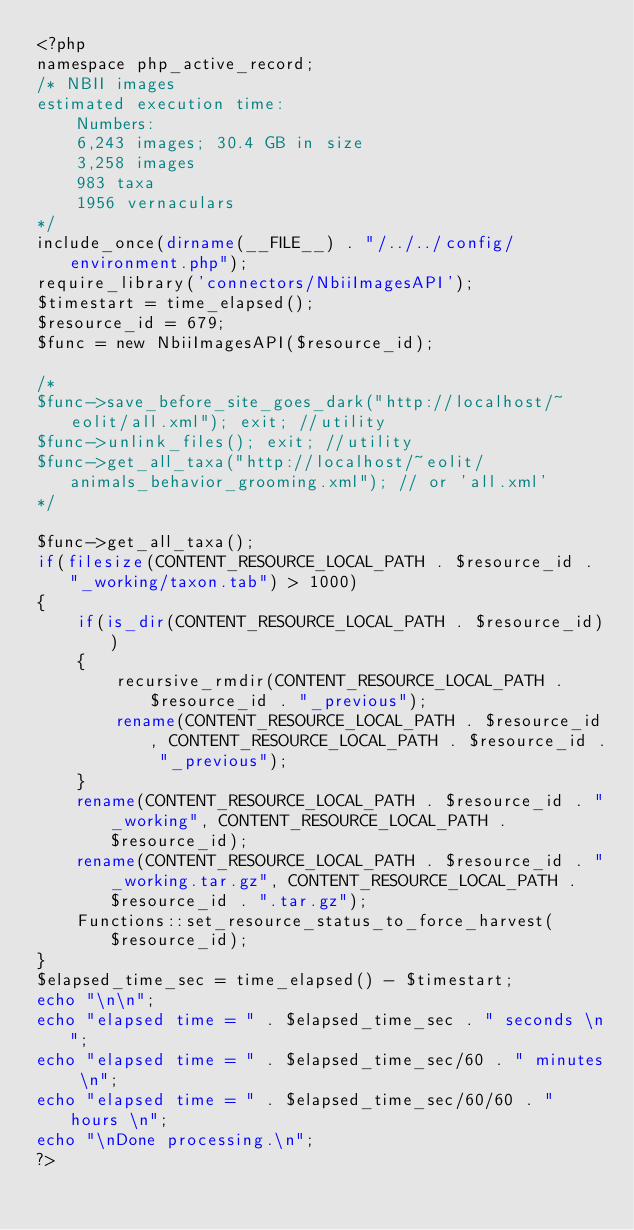<code> <loc_0><loc_0><loc_500><loc_500><_PHP_><?php
namespace php_active_record;
/* NBII images
estimated execution time: 
    Numbers:
    6,243 images; 30.4 GB in size
    3,258 images
    983 taxa
    1956 vernaculars
*/
include_once(dirname(__FILE__) . "/../../config/environment.php");
require_library('connectors/NbiiImagesAPI');
$timestart = time_elapsed();
$resource_id = 679;
$func = new NbiiImagesAPI($resource_id);

/* 
$func->save_before_site_goes_dark("http://localhost/~eolit/all.xml"); exit; //utility
$func->unlink_files(); exit; //utility 
$func->get_all_taxa("http://localhost/~eolit/animals_behavior_grooming.xml"); // or 'all.xml'
*/

$func->get_all_taxa();
if(filesize(CONTENT_RESOURCE_LOCAL_PATH . $resource_id . "_working/taxon.tab") > 1000)
{
    if(is_dir(CONTENT_RESOURCE_LOCAL_PATH . $resource_id))
    {
        recursive_rmdir(CONTENT_RESOURCE_LOCAL_PATH . $resource_id . "_previous");
        rename(CONTENT_RESOURCE_LOCAL_PATH . $resource_id, CONTENT_RESOURCE_LOCAL_PATH . $resource_id . "_previous");
    }
    rename(CONTENT_RESOURCE_LOCAL_PATH . $resource_id . "_working", CONTENT_RESOURCE_LOCAL_PATH . $resource_id);
    rename(CONTENT_RESOURCE_LOCAL_PATH . $resource_id . "_working.tar.gz", CONTENT_RESOURCE_LOCAL_PATH . $resource_id . ".tar.gz");
    Functions::set_resource_status_to_force_harvest($resource_id);
}
$elapsed_time_sec = time_elapsed() - $timestart;
echo "\n\n";
echo "elapsed time = " . $elapsed_time_sec . " seconds \n";
echo "elapsed time = " . $elapsed_time_sec/60 . " minutes \n";
echo "elapsed time = " . $elapsed_time_sec/60/60 . " hours \n";
echo "\nDone processing.\n";
?></code> 